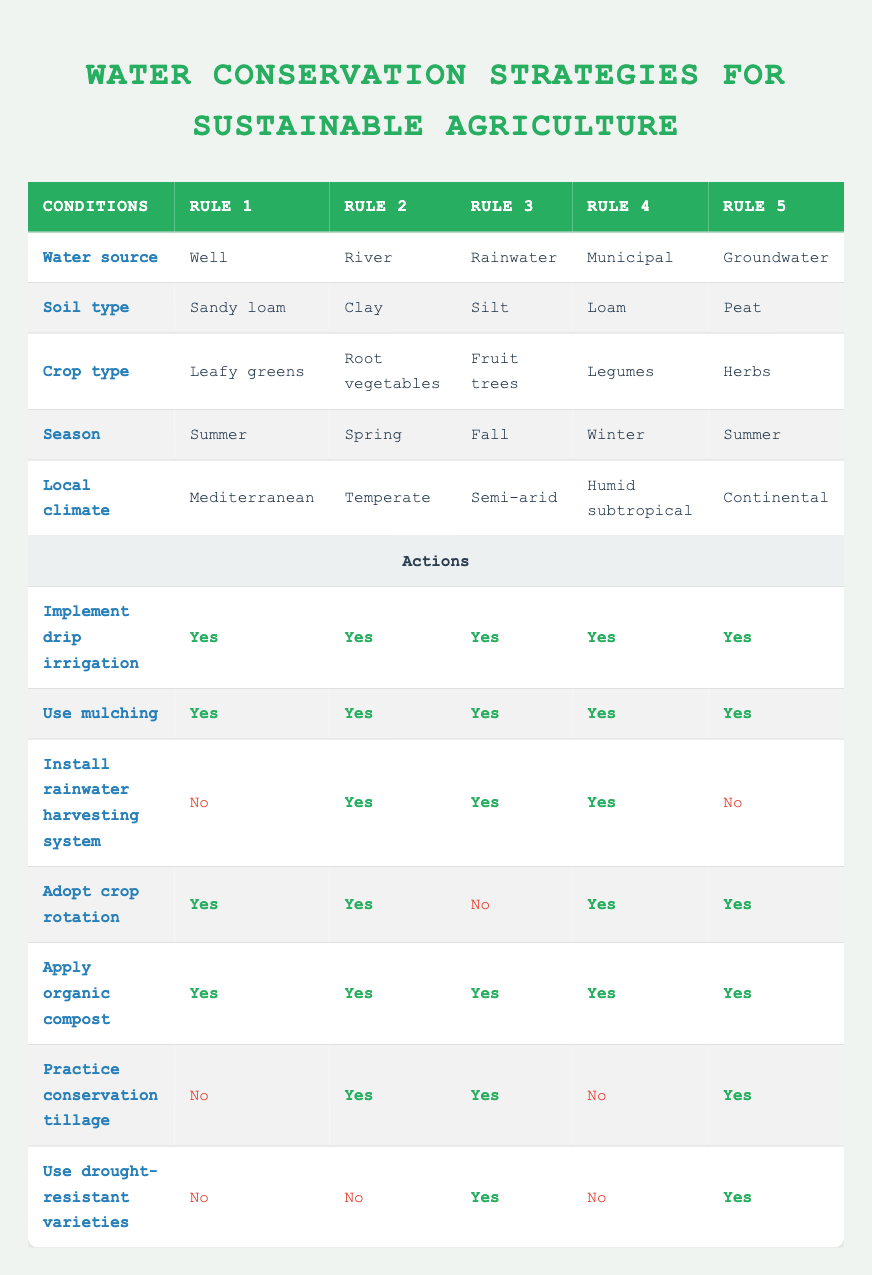What type of water source is used for growing fruit trees in the fall? According to the table, the row under "Crop type" for "Fruit trees" shows that the water source is "Rainwater."
Answer: Rainwater Which crop type utilizes conservation tillage in a temperate climate? Looking at the "Local climate" row, for "Temperate," the action "Practice conservation tillage" is marked as "Yes" for "Root vegetables."
Answer: Root vegetables Do all the rules suggest implementing drip irrigation? All the rows under "Implement drip irrigation" are marked as "Yes," indicating that every rule suggests implementing drip irrigation.
Answer: Yes In how many rules is mulching recommended? Each row under "Use mulching" is marked as "Yes" for all rules, which totals to 5 recommendations. Therefore, mulching is recommended in all 5 rules.
Answer: 5 Which practices are suggested for growing herbs in a continental climate? For "Herbs" in "Continental" climate, the table shows "Implement drip irrigation," "Use mulching," "Adopt crop rotation," "Apply organic compost," "Practice conservation tillage," and "Use drought-resistant varieties." The response is all these mentioned are suggested.
Answer: Drip irrigation, mulching, crop rotation, organic compost, conservation tillage, drought-resistant varieties How many actions are suggested for crops grown with a municipal water source in winter? Referring to the "Municipal" water source during "Winter," the actions are 1) Implement drip irrigation, 2) Use mulching, 3) Install rainwater harvesting system, 4) Adopt crop rotation, 5) Apply organic compost; conservation tillage and drought-resistant varieties are marked as "No," leading to 5 total suggested actions.
Answer: 5 Are drought-resistant varieties recommended for root vegetables in a spring temperate climate? In the "River" row for "Root vegetables" in "Spring," the column "Use drought-resistant varieties" is marked as "No," indicating it is not recommended.
Answer: No Which row shows the most diverse set of recommended actions? The "Rainwater" row under "Silt" for "Fruit trees" suggests 6 actions, the most diverse: 1) Implement drip irrigation, 2) Use mulching, 3) Install rainwater harvesting system, 4) Apply organic compost, 5) Practice conservation tillage, and 6) Use drought-resistant varieties.
Answer: Rainwater (Fruit trees) 